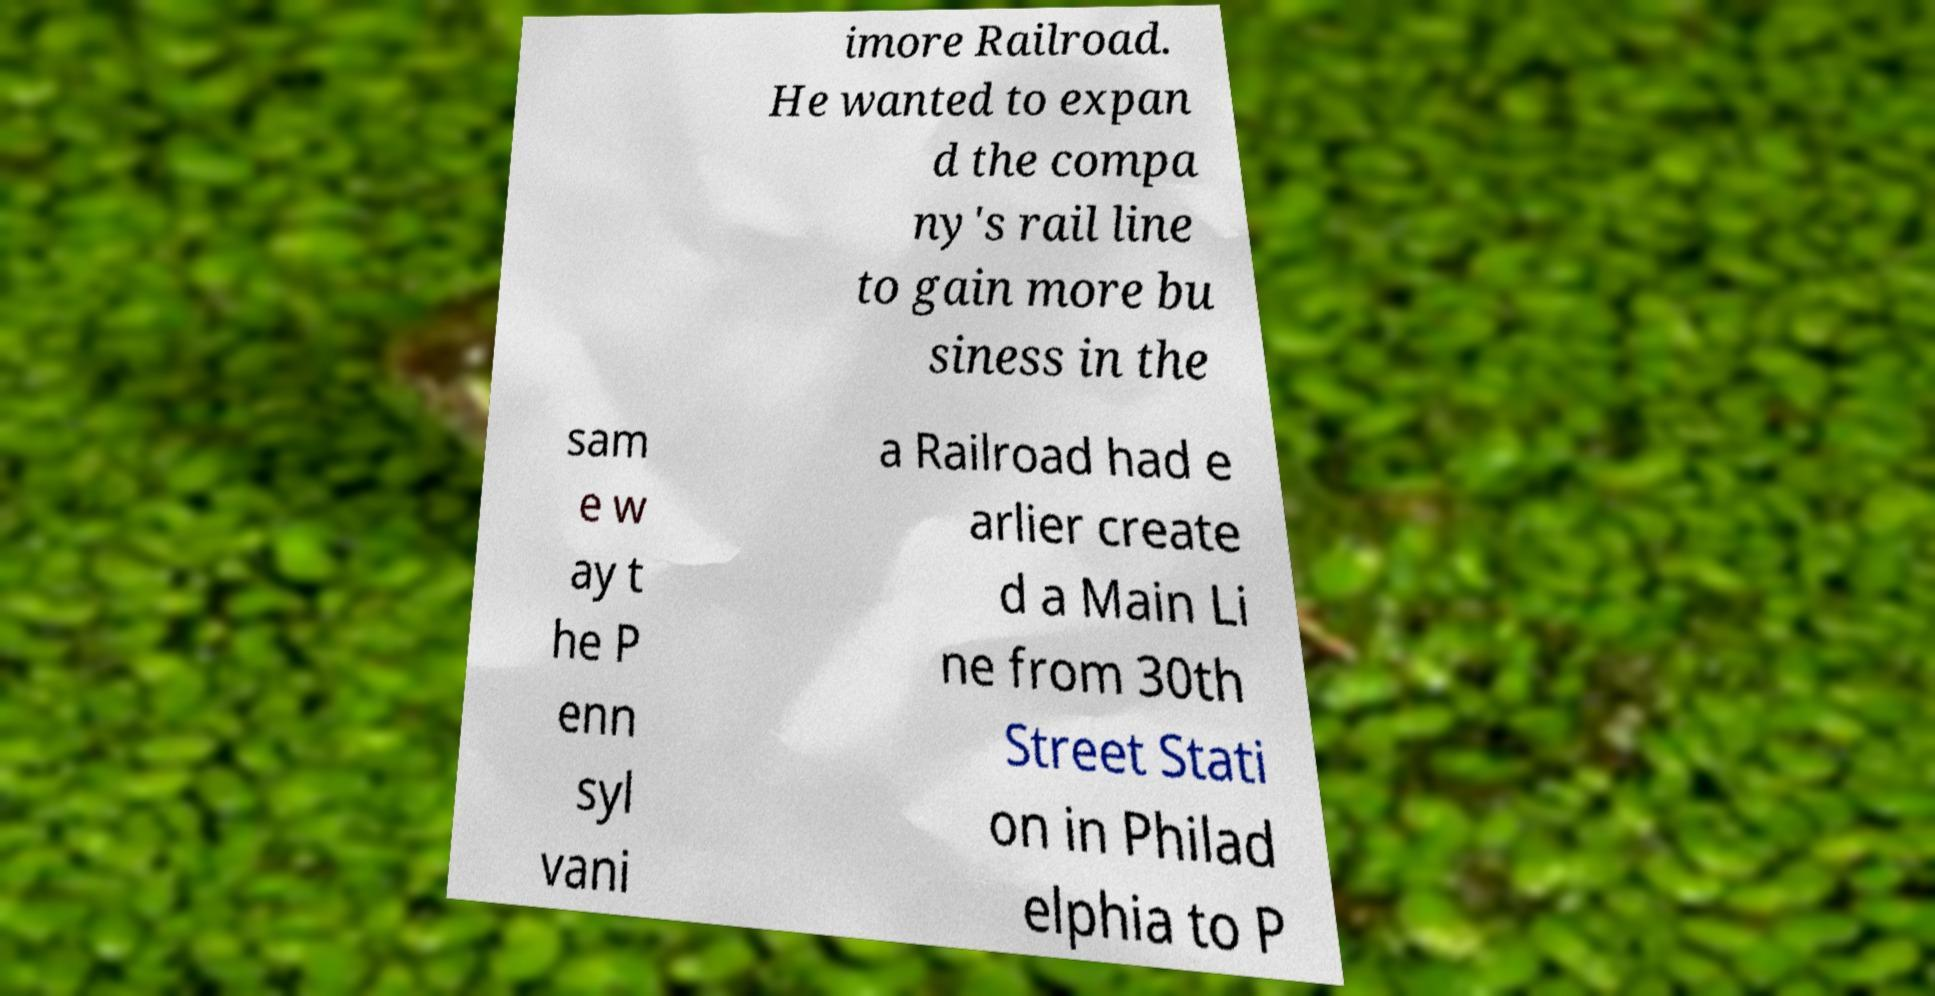Can you accurately transcribe the text from the provided image for me? imore Railroad. He wanted to expan d the compa ny's rail line to gain more bu siness in the sam e w ay t he P enn syl vani a Railroad had e arlier create d a Main Li ne from 30th Street Stati on in Philad elphia to P 